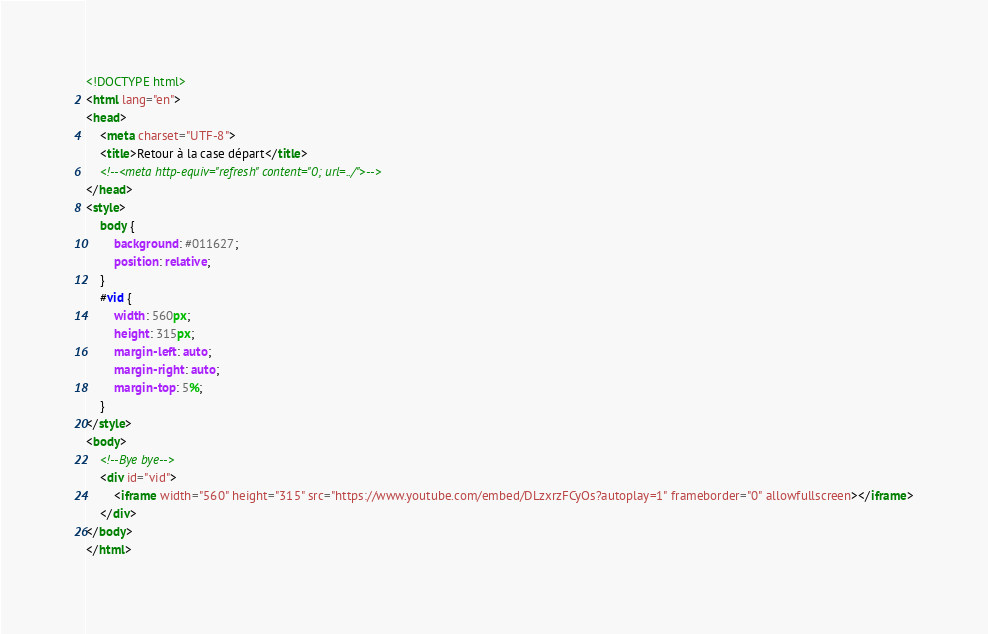<code> <loc_0><loc_0><loc_500><loc_500><_HTML_><!DOCTYPE html>
<html lang="en">
<head>
    <meta charset="UTF-8">
    <title>Retour à la case départ</title>
    <!--<meta http-equiv="refresh" content="0; url=../">-->
</head>
<style>
    body {
        background: #011627;
        position: relative;
    }
    #vid {
        width: 560px;
        height: 315px;
        margin-left: auto;
        margin-right: auto;
        margin-top: 5%;
    }
</style>
<body>
    <!--Bye bye-->
    <div id="vid">
        <iframe width="560" height="315" src="https://www.youtube.com/embed/DLzxrzFCyOs?autoplay=1" frameborder="0" allowfullscreen></iframe>
    </div>
</body>
</html></code> 